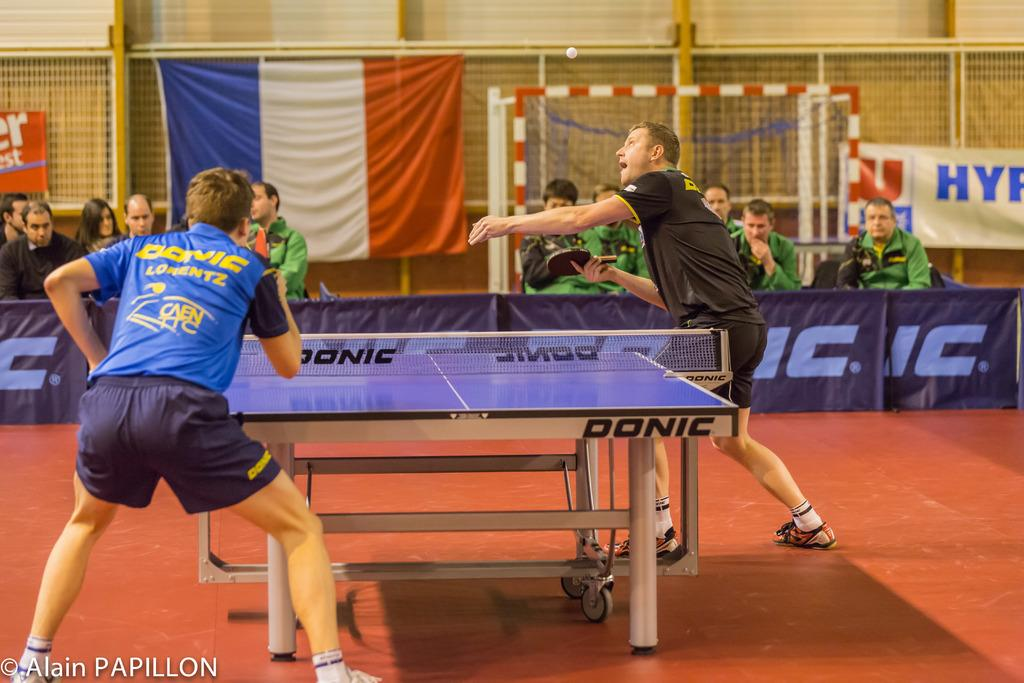What activity is taking place in the image? The image depicts a table tennis game. How many people are actively participating in the game? There are two persons standing and holding rackets. Are there any spectators in the image? Yes, there are persons sitting, which suggests they might be spectators. What decorations can be seen on the wall and around the area? There is a flag on the wall and banners present. What type of weather can be seen in the image? The image does not show any weather conditions, as it is an indoor setting. Can you tell me how many servants are present in the image? There is no mention of servants in the image; it features a table tennis game with participants and spectators. 